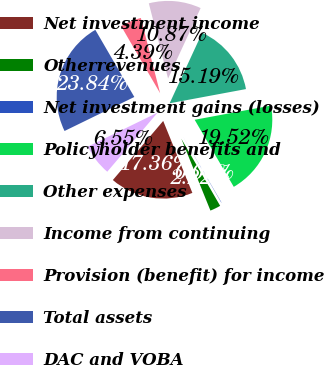Convert chart. <chart><loc_0><loc_0><loc_500><loc_500><pie_chart><fcel>Net investment income<fcel>Otherrevenues<fcel>Net investment gains (losses)<fcel>Policyholder benefits and<fcel>Other expenses<fcel>Income from continuing<fcel>Provision (benefit) for income<fcel>Total assets<fcel>DAC and VOBA<nl><fcel>17.36%<fcel>2.22%<fcel>0.06%<fcel>19.52%<fcel>15.19%<fcel>10.87%<fcel>4.39%<fcel>23.84%<fcel>6.55%<nl></chart> 